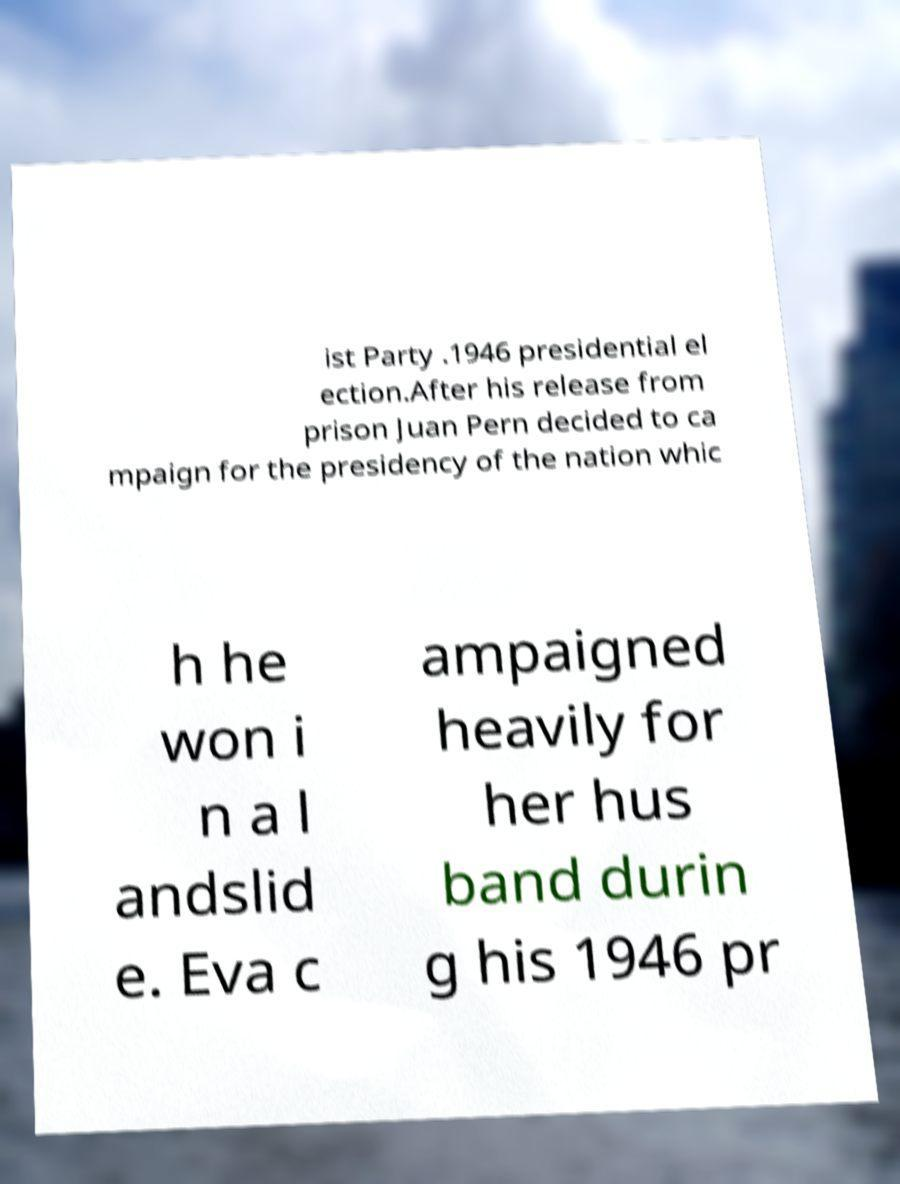Could you assist in decoding the text presented in this image and type it out clearly? ist Party .1946 presidential el ection.After his release from prison Juan Pern decided to ca mpaign for the presidency of the nation whic h he won i n a l andslid e. Eva c ampaigned heavily for her hus band durin g his 1946 pr 